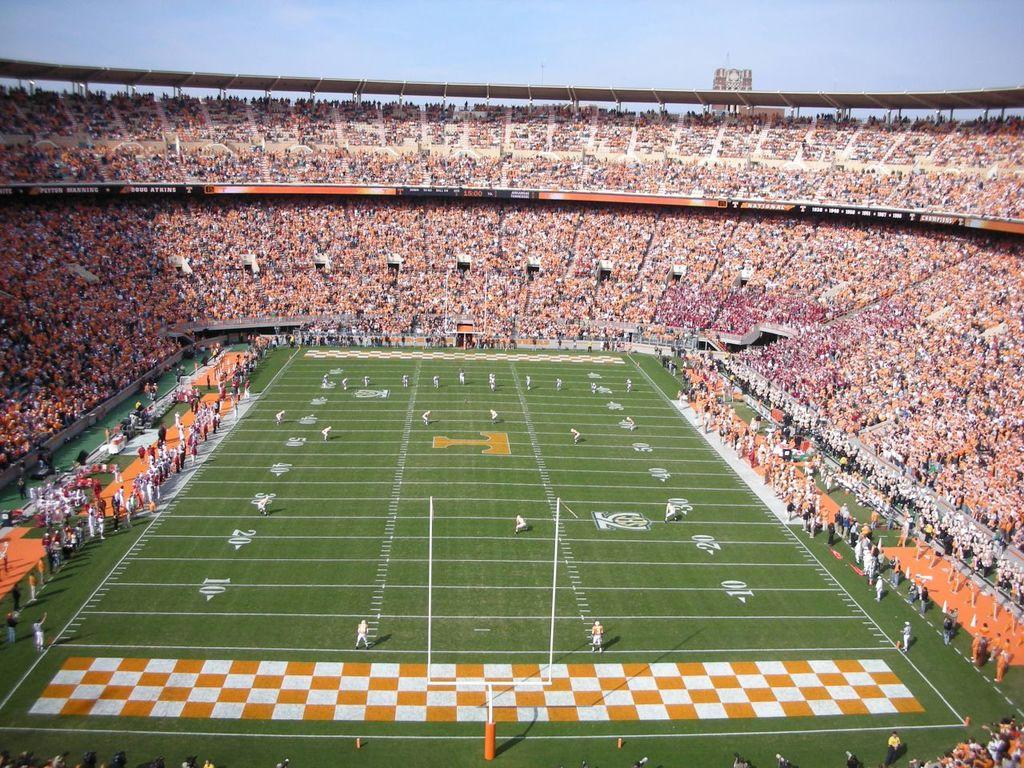What letter can you see on the field?
Make the answer very short. T. 